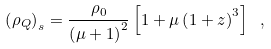<formula> <loc_0><loc_0><loc_500><loc_500>\left ( \rho _ { Q } \right ) _ { s } = \frac { \rho _ { 0 } } { \left ( \mu + 1 \right ) ^ { 2 } } \left [ 1 + \mu \left ( 1 + z \right ) ^ { 3 } \right ] \ ,</formula> 